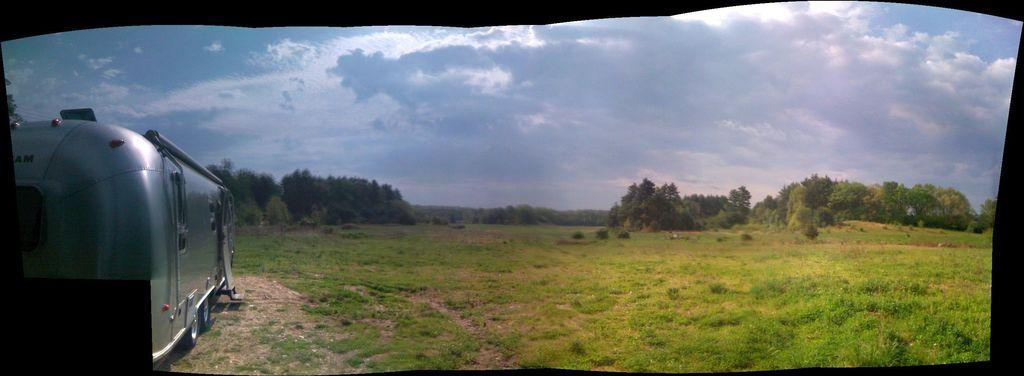What is located on the left side of the image? There is a vehicle on the left side of the image. What type of terrain is visible in the image? There is grass on the ground in the image. What can be seen in the background of the image? There are trees in the background of the image. What is visible in the sky in the image? The sky is visible in the image, and clouds are present. Where is the cork located in the image? There is no cork present in the image. What type of dock can be seen in the image? There is no dock present in the image. 